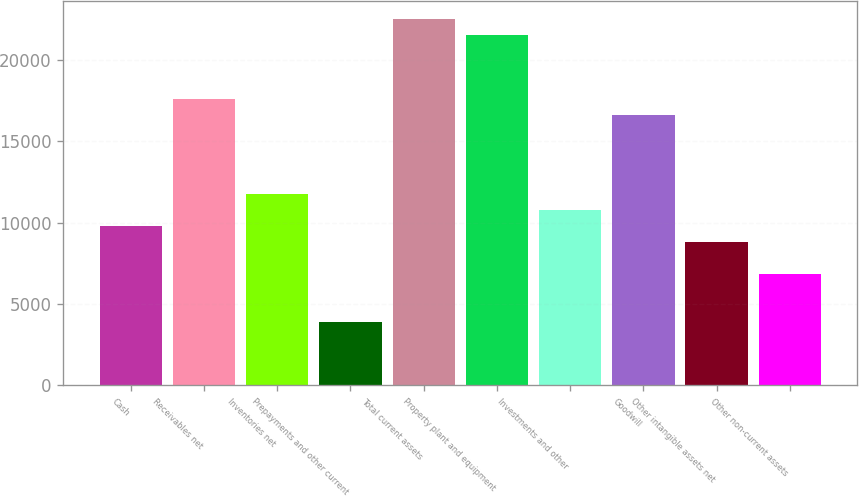Convert chart. <chart><loc_0><loc_0><loc_500><loc_500><bar_chart><fcel>Cash<fcel>Receivables net<fcel>Inventories net<fcel>Prepayments and other current<fcel>Total current assets<fcel>Property plant and equipment<fcel>Investments and other<fcel>Goodwill<fcel>Other intangible assets net<fcel>Other non-current assets<nl><fcel>9787.6<fcel>17615.7<fcel>11744.6<fcel>3916.54<fcel>22508.2<fcel>21529.7<fcel>10766.1<fcel>16637.2<fcel>8809.09<fcel>6852.07<nl></chart> 